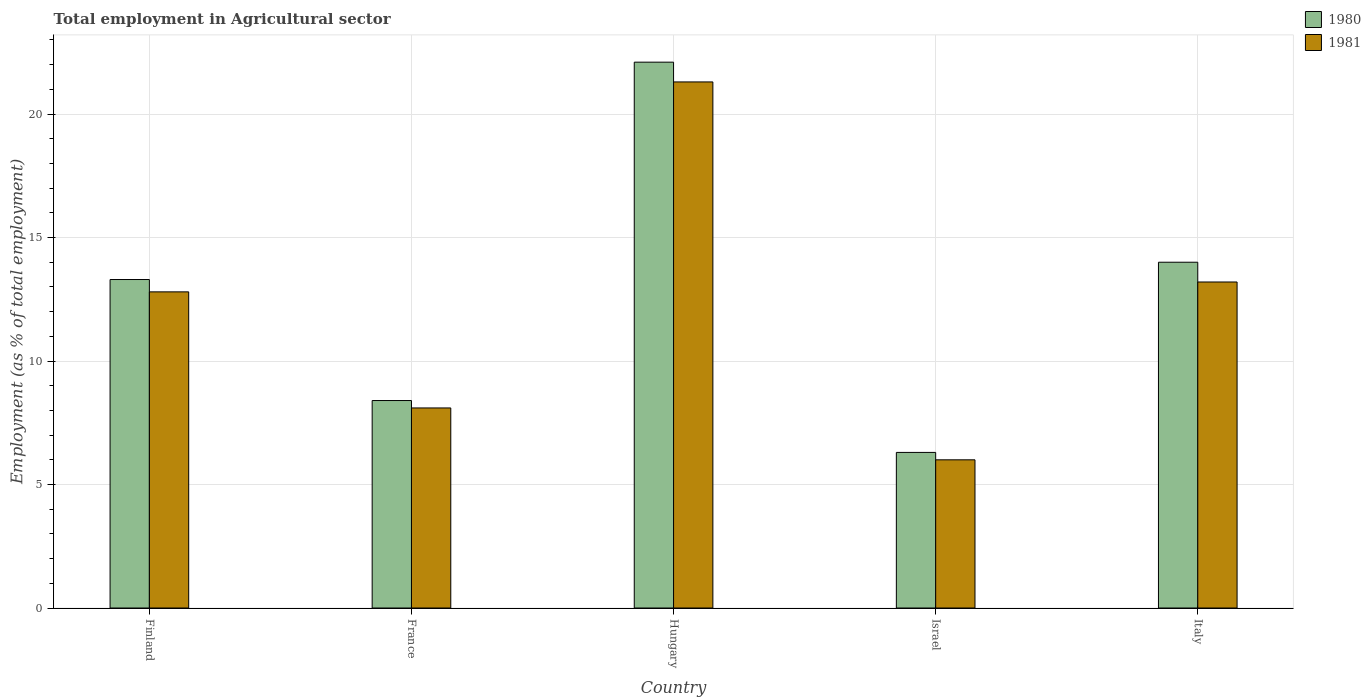How many different coloured bars are there?
Provide a short and direct response. 2. How many groups of bars are there?
Provide a short and direct response. 5. Are the number of bars per tick equal to the number of legend labels?
Offer a very short reply. Yes. Are the number of bars on each tick of the X-axis equal?
Your answer should be very brief. Yes. What is the employment in agricultural sector in 1980 in Finland?
Provide a short and direct response. 13.3. Across all countries, what is the maximum employment in agricultural sector in 1980?
Offer a terse response. 22.1. In which country was the employment in agricultural sector in 1980 maximum?
Give a very brief answer. Hungary. What is the total employment in agricultural sector in 1980 in the graph?
Keep it short and to the point. 64.1. What is the difference between the employment in agricultural sector in 1981 in Finland and that in Israel?
Make the answer very short. 6.8. What is the difference between the employment in agricultural sector in 1981 in Hungary and the employment in agricultural sector in 1980 in Israel?
Ensure brevity in your answer.  15. What is the average employment in agricultural sector in 1981 per country?
Offer a terse response. 12.28. What is the difference between the employment in agricultural sector of/in 1981 and employment in agricultural sector of/in 1980 in Hungary?
Ensure brevity in your answer.  -0.8. What is the ratio of the employment in agricultural sector in 1980 in Israel to that in Italy?
Offer a very short reply. 0.45. Is the employment in agricultural sector in 1980 in Finland less than that in Hungary?
Offer a terse response. Yes. Is the difference between the employment in agricultural sector in 1981 in France and Hungary greater than the difference between the employment in agricultural sector in 1980 in France and Hungary?
Your answer should be compact. Yes. What is the difference between the highest and the second highest employment in agricultural sector in 1980?
Your response must be concise. -8.8. What is the difference between the highest and the lowest employment in agricultural sector in 1980?
Offer a very short reply. 15.8. In how many countries, is the employment in agricultural sector in 1981 greater than the average employment in agricultural sector in 1981 taken over all countries?
Ensure brevity in your answer.  3. Is the sum of the employment in agricultural sector in 1981 in France and Italy greater than the maximum employment in agricultural sector in 1980 across all countries?
Provide a succinct answer. No. What does the 2nd bar from the right in Italy represents?
Provide a short and direct response. 1980. Are all the bars in the graph horizontal?
Give a very brief answer. No. What is the difference between two consecutive major ticks on the Y-axis?
Make the answer very short. 5. Are the values on the major ticks of Y-axis written in scientific E-notation?
Your response must be concise. No. Does the graph contain any zero values?
Your answer should be very brief. No. How many legend labels are there?
Your response must be concise. 2. What is the title of the graph?
Make the answer very short. Total employment in Agricultural sector. What is the label or title of the Y-axis?
Provide a succinct answer. Employment (as % of total employment). What is the Employment (as % of total employment) of 1980 in Finland?
Your answer should be compact. 13.3. What is the Employment (as % of total employment) of 1981 in Finland?
Provide a succinct answer. 12.8. What is the Employment (as % of total employment) in 1980 in France?
Your answer should be very brief. 8.4. What is the Employment (as % of total employment) in 1981 in France?
Offer a very short reply. 8.1. What is the Employment (as % of total employment) of 1980 in Hungary?
Your response must be concise. 22.1. What is the Employment (as % of total employment) of 1981 in Hungary?
Offer a very short reply. 21.3. What is the Employment (as % of total employment) of 1980 in Israel?
Ensure brevity in your answer.  6.3. What is the Employment (as % of total employment) of 1980 in Italy?
Offer a very short reply. 14. What is the Employment (as % of total employment) of 1981 in Italy?
Ensure brevity in your answer.  13.2. Across all countries, what is the maximum Employment (as % of total employment) in 1980?
Your response must be concise. 22.1. Across all countries, what is the maximum Employment (as % of total employment) in 1981?
Offer a very short reply. 21.3. Across all countries, what is the minimum Employment (as % of total employment) of 1980?
Your answer should be very brief. 6.3. What is the total Employment (as % of total employment) in 1980 in the graph?
Your answer should be very brief. 64.1. What is the total Employment (as % of total employment) of 1981 in the graph?
Your response must be concise. 61.4. What is the difference between the Employment (as % of total employment) in 1980 in Finland and that in France?
Make the answer very short. 4.9. What is the difference between the Employment (as % of total employment) in 1980 in Finland and that in Hungary?
Provide a succinct answer. -8.8. What is the difference between the Employment (as % of total employment) of 1981 in Finland and that in Hungary?
Your response must be concise. -8.5. What is the difference between the Employment (as % of total employment) of 1981 in Finland and that in Israel?
Your answer should be very brief. 6.8. What is the difference between the Employment (as % of total employment) in 1981 in Finland and that in Italy?
Provide a short and direct response. -0.4. What is the difference between the Employment (as % of total employment) of 1980 in France and that in Hungary?
Give a very brief answer. -13.7. What is the difference between the Employment (as % of total employment) of 1980 in France and that in Italy?
Your answer should be very brief. -5.6. What is the difference between the Employment (as % of total employment) in 1981 in France and that in Italy?
Offer a terse response. -5.1. What is the difference between the Employment (as % of total employment) of 1980 in Hungary and that in Italy?
Make the answer very short. 8.1. What is the difference between the Employment (as % of total employment) of 1981 in Israel and that in Italy?
Your response must be concise. -7.2. What is the difference between the Employment (as % of total employment) in 1980 in Finland and the Employment (as % of total employment) in 1981 in France?
Ensure brevity in your answer.  5.2. What is the difference between the Employment (as % of total employment) in 1980 in Finland and the Employment (as % of total employment) in 1981 in Hungary?
Provide a succinct answer. -8. What is the difference between the Employment (as % of total employment) of 1980 in Finland and the Employment (as % of total employment) of 1981 in Israel?
Your response must be concise. 7.3. What is the difference between the Employment (as % of total employment) of 1980 in Finland and the Employment (as % of total employment) of 1981 in Italy?
Provide a succinct answer. 0.1. What is the difference between the Employment (as % of total employment) of 1980 in France and the Employment (as % of total employment) of 1981 in Hungary?
Make the answer very short. -12.9. What is the difference between the Employment (as % of total employment) of 1980 in France and the Employment (as % of total employment) of 1981 in Israel?
Your answer should be compact. 2.4. What is the difference between the Employment (as % of total employment) of 1980 in France and the Employment (as % of total employment) of 1981 in Italy?
Your answer should be compact. -4.8. What is the difference between the Employment (as % of total employment) of 1980 in Hungary and the Employment (as % of total employment) of 1981 in Israel?
Offer a terse response. 16.1. What is the difference between the Employment (as % of total employment) of 1980 in Israel and the Employment (as % of total employment) of 1981 in Italy?
Ensure brevity in your answer.  -6.9. What is the average Employment (as % of total employment) in 1980 per country?
Provide a succinct answer. 12.82. What is the average Employment (as % of total employment) in 1981 per country?
Your answer should be very brief. 12.28. What is the difference between the Employment (as % of total employment) of 1980 and Employment (as % of total employment) of 1981 in France?
Offer a very short reply. 0.3. What is the difference between the Employment (as % of total employment) of 1980 and Employment (as % of total employment) of 1981 in Hungary?
Your response must be concise. 0.8. What is the difference between the Employment (as % of total employment) of 1980 and Employment (as % of total employment) of 1981 in Israel?
Your answer should be very brief. 0.3. What is the ratio of the Employment (as % of total employment) of 1980 in Finland to that in France?
Provide a short and direct response. 1.58. What is the ratio of the Employment (as % of total employment) in 1981 in Finland to that in France?
Offer a very short reply. 1.58. What is the ratio of the Employment (as % of total employment) of 1980 in Finland to that in Hungary?
Give a very brief answer. 0.6. What is the ratio of the Employment (as % of total employment) in 1981 in Finland to that in Hungary?
Offer a very short reply. 0.6. What is the ratio of the Employment (as % of total employment) of 1980 in Finland to that in Israel?
Provide a short and direct response. 2.11. What is the ratio of the Employment (as % of total employment) of 1981 in Finland to that in Israel?
Give a very brief answer. 2.13. What is the ratio of the Employment (as % of total employment) of 1980 in Finland to that in Italy?
Your answer should be very brief. 0.95. What is the ratio of the Employment (as % of total employment) in 1981 in Finland to that in Italy?
Your answer should be very brief. 0.97. What is the ratio of the Employment (as % of total employment) of 1980 in France to that in Hungary?
Your response must be concise. 0.38. What is the ratio of the Employment (as % of total employment) in 1981 in France to that in Hungary?
Ensure brevity in your answer.  0.38. What is the ratio of the Employment (as % of total employment) in 1980 in France to that in Israel?
Your response must be concise. 1.33. What is the ratio of the Employment (as % of total employment) in 1981 in France to that in Israel?
Provide a short and direct response. 1.35. What is the ratio of the Employment (as % of total employment) of 1981 in France to that in Italy?
Your response must be concise. 0.61. What is the ratio of the Employment (as % of total employment) of 1980 in Hungary to that in Israel?
Offer a terse response. 3.51. What is the ratio of the Employment (as % of total employment) in 1981 in Hungary to that in Israel?
Ensure brevity in your answer.  3.55. What is the ratio of the Employment (as % of total employment) in 1980 in Hungary to that in Italy?
Keep it short and to the point. 1.58. What is the ratio of the Employment (as % of total employment) in 1981 in Hungary to that in Italy?
Make the answer very short. 1.61. What is the ratio of the Employment (as % of total employment) in 1980 in Israel to that in Italy?
Your answer should be compact. 0.45. What is the ratio of the Employment (as % of total employment) in 1981 in Israel to that in Italy?
Provide a succinct answer. 0.45. 